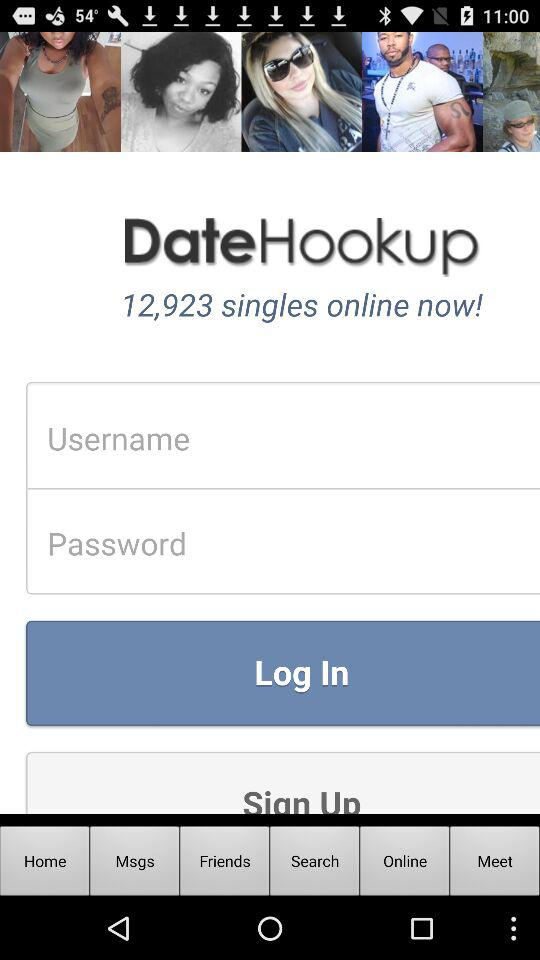What is the application name? The application name is "DateHookup". 